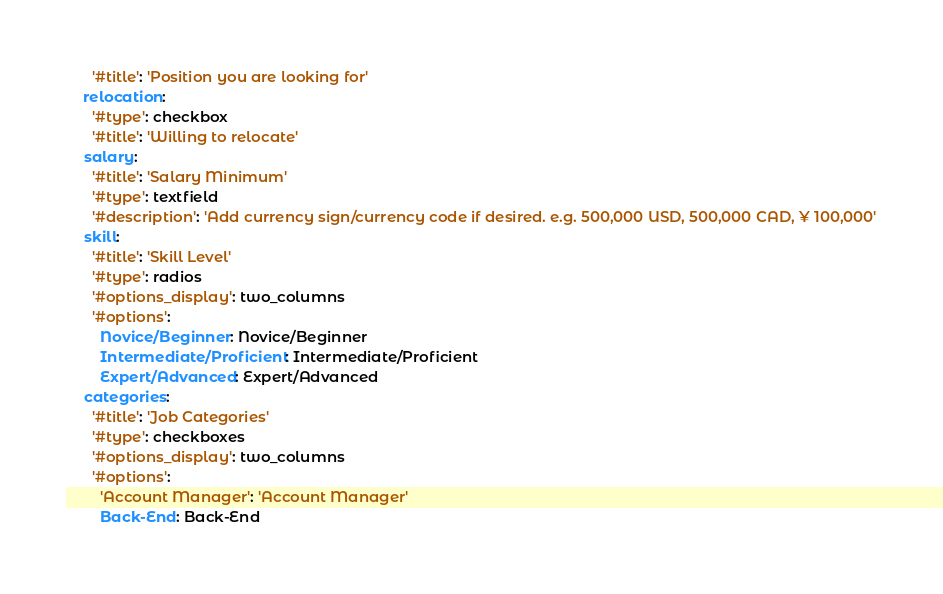Convert code to text. <code><loc_0><loc_0><loc_500><loc_500><_YAML_>      '#title': 'Position you are looking for'
    relocation:
      '#type': checkbox
      '#title': 'Willing to relocate'
    salary:
      '#title': 'Salary Minimum'
      '#type': textfield
      '#description': 'Add currency sign/currency code if desired. e.g. 500,000 USD, 500,000 CAD, ¥ 100,000'
    skill:
      '#title': 'Skill Level'
      '#type': radios
      '#options_display': two_columns
      '#options':
        Novice/Beginner: Novice/Beginner
        Intermediate/Proficient: Intermediate/Proficient
        Expert/Advanced: Expert/Advanced
    categories:
      '#title': 'Job Categories'
      '#type': checkboxes
      '#options_display': two_columns
      '#options':
        'Account Manager': 'Account Manager'
        Back-End: Back-End</code> 